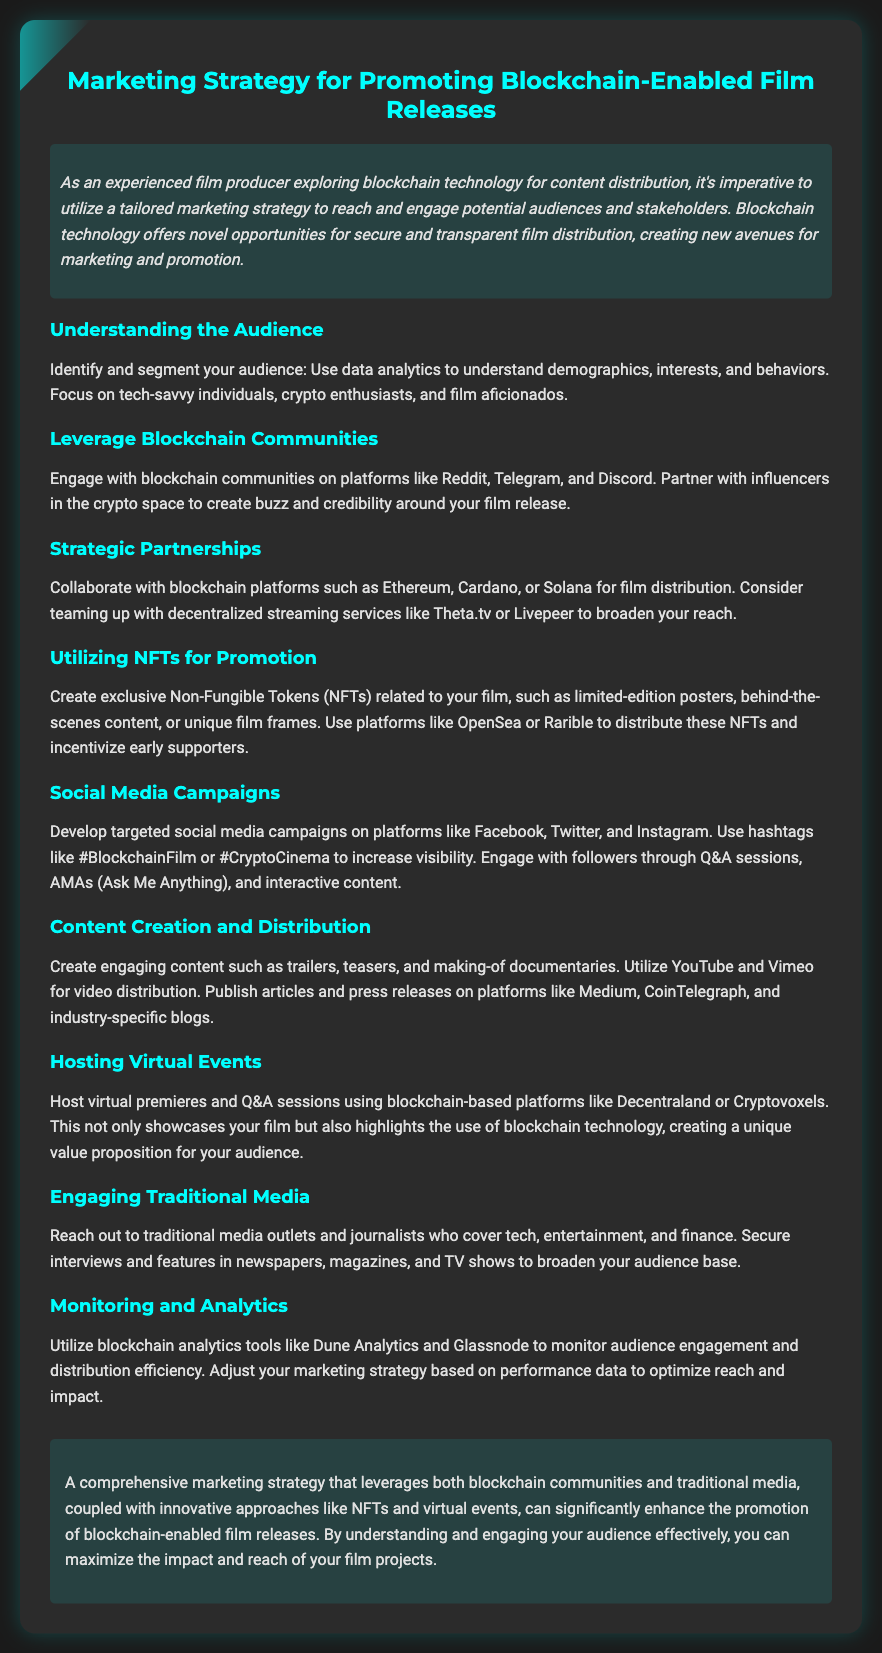What is the title of the document? The title of the document is mentioned prominently at the top and provides the primary focus of the content.
Answer: Marketing Strategy for Promoting Blockchain-Enabled Film Releases What is a key audience segment mentioned? The document states that it's important to focus on tech-savvy individuals, crypto enthusiasts, and film aficionados when identifying the audience.
Answer: Tech-savvy individuals Which platform is suggested for creating NFTs? The document specifies platforms that can be utilized for NFT distribution related to the film, highlighting this as a promotional strategy.
Answer: OpenSea What is one benefit of engaging blockchain communities? The document indicates that engaging with blockchain communities can generate buzz and credibility, enhancing the marketing efforts for the film release.
Answer: Buzz and credibility Which social media platforms are recommended for campaigns? The document lists social media platforms which are ideal for promoting blockchain-enabled films to reach a wider audience.
Answer: Facebook, Twitter, and Instagram What type of content should be created for promotion? The document mentions specific types of content that can be created to engage audiences and promote the film effectively, making it clear what producers should focus on.
Answer: Trailers, teasers, and making-of documentaries What is one method for monitoring audience engagement? The document highlights the use of certain analytics tools to gauge audience interactions and refine the marketing approach as necessary.
Answer: Dune Analytics What kind of events should be hosted for promotion? The document suggests a specific type of event to host which can enhance audience engagement while showcasing the film and its technology.
Answer: Virtual premieres What is emphasized as a necessary step for maximizing film reach? The document concludes by highlighting the importance of a comprehensive strategy that utilizes various channels and mechanisms for effective film promotion.
Answer: Engaging your audience effectively 